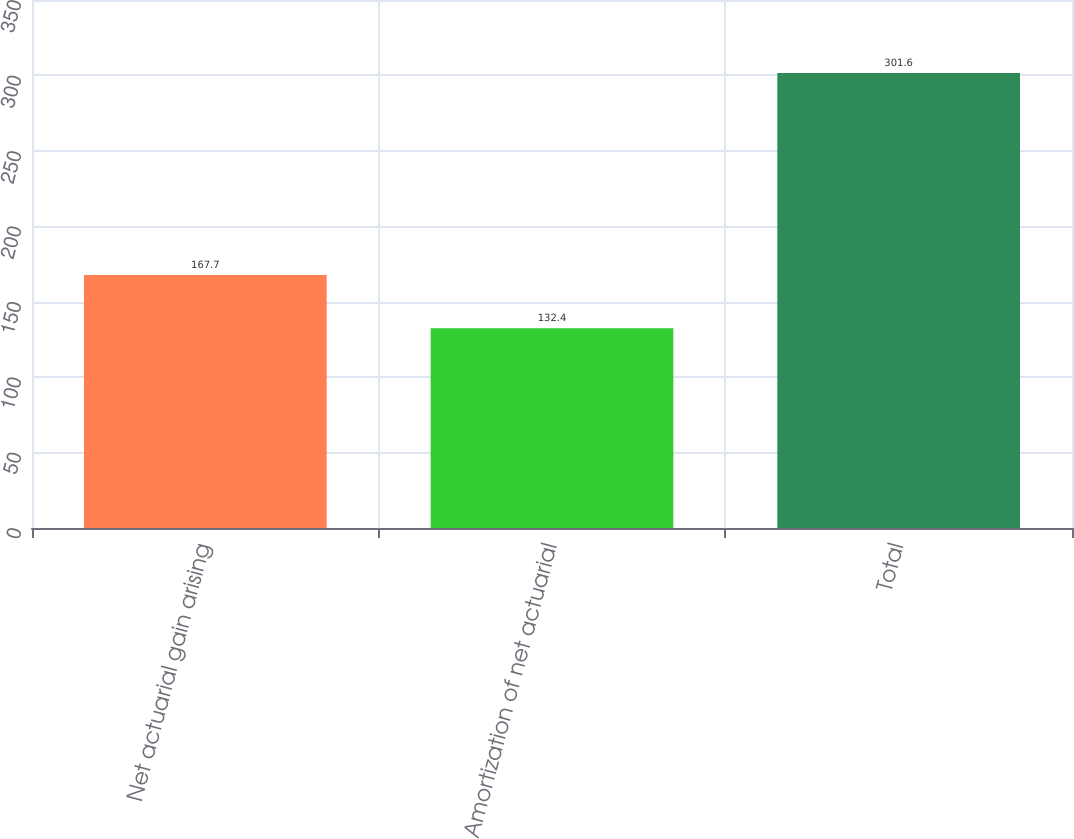Convert chart to OTSL. <chart><loc_0><loc_0><loc_500><loc_500><bar_chart><fcel>Net actuarial gain arising<fcel>Amortization of net actuarial<fcel>Total<nl><fcel>167.7<fcel>132.4<fcel>301.6<nl></chart> 